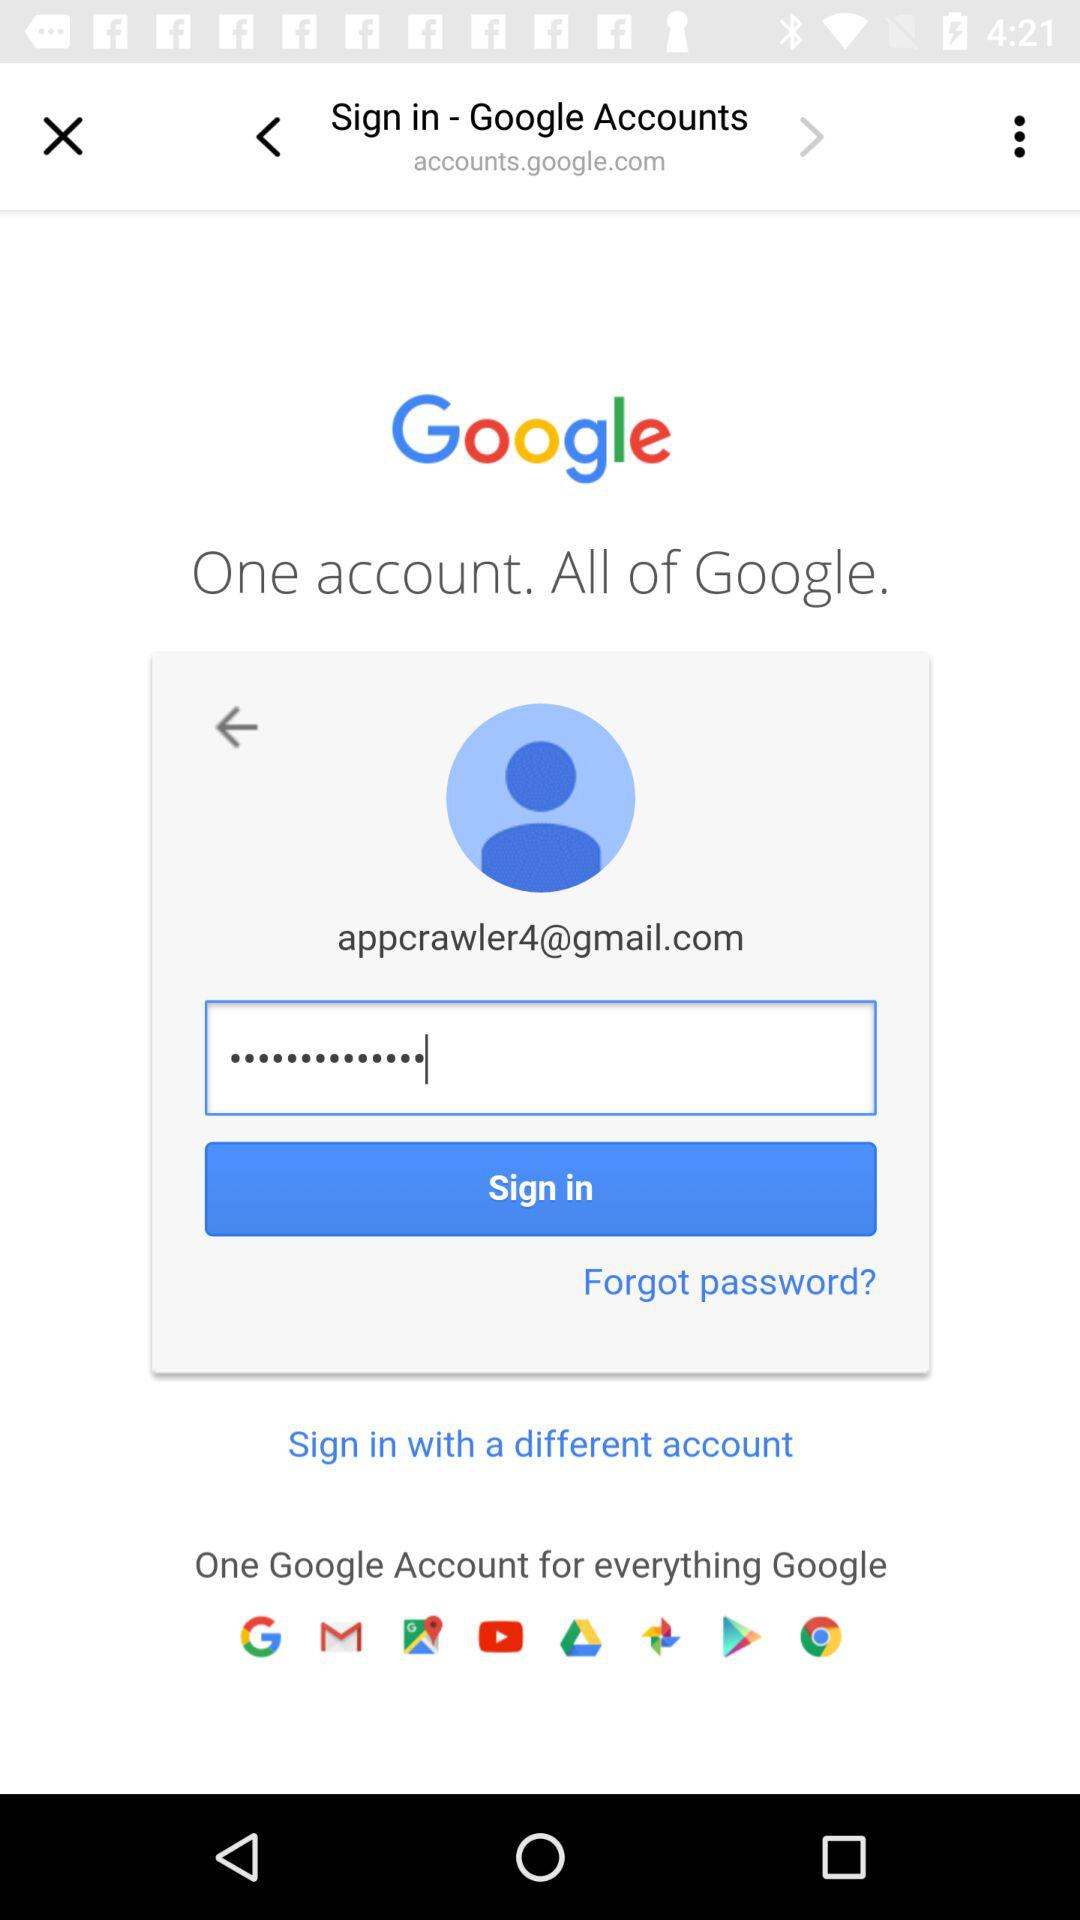What is the email address? The email address is appcrawler4@gmail.com. 